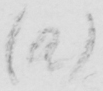Can you read and transcribe this handwriting? ( a ) 